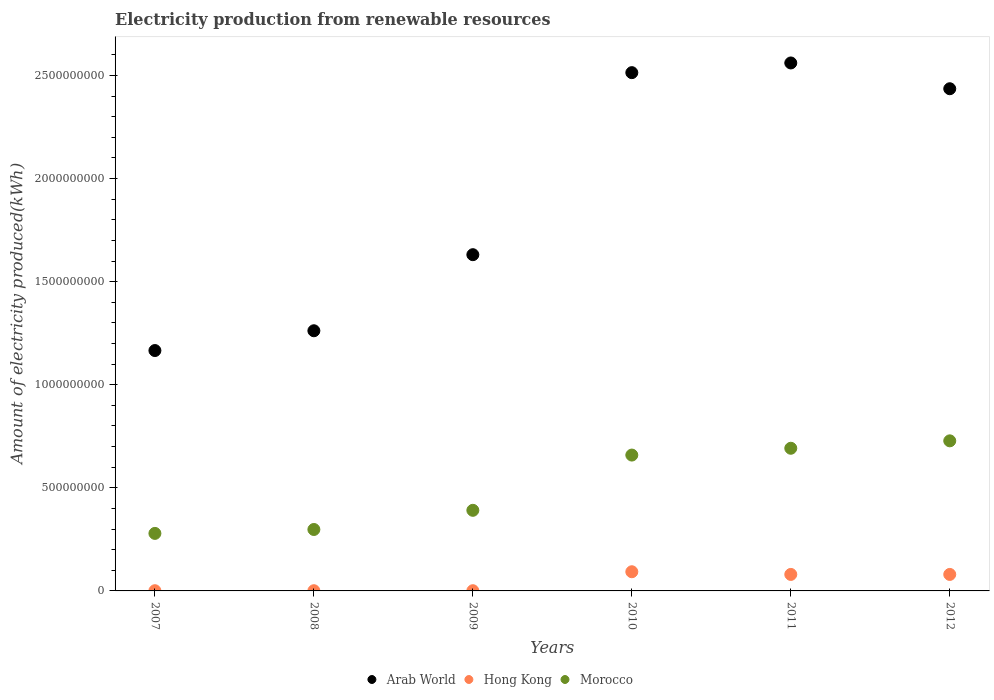How many different coloured dotlines are there?
Provide a short and direct response. 3. What is the amount of electricity produced in Morocco in 2009?
Offer a terse response. 3.91e+08. Across all years, what is the maximum amount of electricity produced in Arab World?
Offer a terse response. 2.56e+09. Across all years, what is the minimum amount of electricity produced in Hong Kong?
Give a very brief answer. 1.00e+06. In which year was the amount of electricity produced in Hong Kong minimum?
Ensure brevity in your answer.  2007. What is the total amount of electricity produced in Arab World in the graph?
Provide a short and direct response. 1.16e+1. What is the difference between the amount of electricity produced in Morocco in 2009 and that in 2012?
Offer a terse response. -3.37e+08. What is the difference between the amount of electricity produced in Morocco in 2012 and the amount of electricity produced in Arab World in 2010?
Your answer should be compact. -1.79e+09. What is the average amount of electricity produced in Arab World per year?
Your answer should be compact. 1.93e+09. In the year 2008, what is the difference between the amount of electricity produced in Hong Kong and amount of electricity produced in Morocco?
Your response must be concise. -2.97e+08. In how many years, is the amount of electricity produced in Arab World greater than 1300000000 kWh?
Make the answer very short. 4. What is the ratio of the amount of electricity produced in Arab World in 2008 to that in 2011?
Provide a short and direct response. 0.49. Is the difference between the amount of electricity produced in Hong Kong in 2010 and 2012 greater than the difference between the amount of electricity produced in Morocco in 2010 and 2012?
Your answer should be compact. Yes. What is the difference between the highest and the second highest amount of electricity produced in Morocco?
Ensure brevity in your answer.  3.60e+07. What is the difference between the highest and the lowest amount of electricity produced in Morocco?
Make the answer very short. 4.49e+08. Is the sum of the amount of electricity produced in Arab World in 2011 and 2012 greater than the maximum amount of electricity produced in Hong Kong across all years?
Your answer should be compact. Yes. Is it the case that in every year, the sum of the amount of electricity produced in Arab World and amount of electricity produced in Hong Kong  is greater than the amount of electricity produced in Morocco?
Keep it short and to the point. Yes. Is the amount of electricity produced in Hong Kong strictly less than the amount of electricity produced in Morocco over the years?
Make the answer very short. Yes. How many dotlines are there?
Offer a terse response. 3. Are the values on the major ticks of Y-axis written in scientific E-notation?
Your answer should be compact. No. Where does the legend appear in the graph?
Give a very brief answer. Bottom center. How many legend labels are there?
Keep it short and to the point. 3. How are the legend labels stacked?
Keep it short and to the point. Horizontal. What is the title of the graph?
Your answer should be compact. Electricity production from renewable resources. Does "Afghanistan" appear as one of the legend labels in the graph?
Offer a terse response. No. What is the label or title of the X-axis?
Your answer should be very brief. Years. What is the label or title of the Y-axis?
Keep it short and to the point. Amount of electricity produced(kWh). What is the Amount of electricity produced(kWh) in Arab World in 2007?
Make the answer very short. 1.17e+09. What is the Amount of electricity produced(kWh) in Hong Kong in 2007?
Provide a short and direct response. 1.00e+06. What is the Amount of electricity produced(kWh) of Morocco in 2007?
Offer a very short reply. 2.79e+08. What is the Amount of electricity produced(kWh) in Arab World in 2008?
Provide a short and direct response. 1.26e+09. What is the Amount of electricity produced(kWh) in Hong Kong in 2008?
Offer a terse response. 1.00e+06. What is the Amount of electricity produced(kWh) of Morocco in 2008?
Your response must be concise. 2.98e+08. What is the Amount of electricity produced(kWh) of Arab World in 2009?
Keep it short and to the point. 1.63e+09. What is the Amount of electricity produced(kWh) of Morocco in 2009?
Your answer should be compact. 3.91e+08. What is the Amount of electricity produced(kWh) in Arab World in 2010?
Give a very brief answer. 2.51e+09. What is the Amount of electricity produced(kWh) in Hong Kong in 2010?
Keep it short and to the point. 9.30e+07. What is the Amount of electricity produced(kWh) in Morocco in 2010?
Provide a short and direct response. 6.59e+08. What is the Amount of electricity produced(kWh) in Arab World in 2011?
Provide a succinct answer. 2.56e+09. What is the Amount of electricity produced(kWh) of Hong Kong in 2011?
Offer a terse response. 8.00e+07. What is the Amount of electricity produced(kWh) of Morocco in 2011?
Offer a terse response. 6.92e+08. What is the Amount of electricity produced(kWh) in Arab World in 2012?
Your answer should be compact. 2.44e+09. What is the Amount of electricity produced(kWh) of Hong Kong in 2012?
Your answer should be compact. 8.00e+07. What is the Amount of electricity produced(kWh) of Morocco in 2012?
Ensure brevity in your answer.  7.28e+08. Across all years, what is the maximum Amount of electricity produced(kWh) of Arab World?
Make the answer very short. 2.56e+09. Across all years, what is the maximum Amount of electricity produced(kWh) of Hong Kong?
Give a very brief answer. 9.30e+07. Across all years, what is the maximum Amount of electricity produced(kWh) in Morocco?
Give a very brief answer. 7.28e+08. Across all years, what is the minimum Amount of electricity produced(kWh) of Arab World?
Provide a short and direct response. 1.17e+09. Across all years, what is the minimum Amount of electricity produced(kWh) of Hong Kong?
Offer a very short reply. 1.00e+06. Across all years, what is the minimum Amount of electricity produced(kWh) in Morocco?
Provide a succinct answer. 2.79e+08. What is the total Amount of electricity produced(kWh) in Arab World in the graph?
Your answer should be compact. 1.16e+1. What is the total Amount of electricity produced(kWh) in Hong Kong in the graph?
Keep it short and to the point. 2.56e+08. What is the total Amount of electricity produced(kWh) of Morocco in the graph?
Offer a very short reply. 3.05e+09. What is the difference between the Amount of electricity produced(kWh) of Arab World in 2007 and that in 2008?
Ensure brevity in your answer.  -9.60e+07. What is the difference between the Amount of electricity produced(kWh) in Hong Kong in 2007 and that in 2008?
Offer a very short reply. 0. What is the difference between the Amount of electricity produced(kWh) of Morocco in 2007 and that in 2008?
Provide a short and direct response. -1.90e+07. What is the difference between the Amount of electricity produced(kWh) in Arab World in 2007 and that in 2009?
Your answer should be compact. -4.65e+08. What is the difference between the Amount of electricity produced(kWh) in Morocco in 2007 and that in 2009?
Keep it short and to the point. -1.12e+08. What is the difference between the Amount of electricity produced(kWh) of Arab World in 2007 and that in 2010?
Provide a succinct answer. -1.35e+09. What is the difference between the Amount of electricity produced(kWh) in Hong Kong in 2007 and that in 2010?
Provide a succinct answer. -9.20e+07. What is the difference between the Amount of electricity produced(kWh) in Morocco in 2007 and that in 2010?
Provide a short and direct response. -3.80e+08. What is the difference between the Amount of electricity produced(kWh) of Arab World in 2007 and that in 2011?
Ensure brevity in your answer.  -1.40e+09. What is the difference between the Amount of electricity produced(kWh) of Hong Kong in 2007 and that in 2011?
Provide a succinct answer. -7.90e+07. What is the difference between the Amount of electricity produced(kWh) in Morocco in 2007 and that in 2011?
Keep it short and to the point. -4.13e+08. What is the difference between the Amount of electricity produced(kWh) of Arab World in 2007 and that in 2012?
Your answer should be compact. -1.27e+09. What is the difference between the Amount of electricity produced(kWh) in Hong Kong in 2007 and that in 2012?
Offer a very short reply. -7.90e+07. What is the difference between the Amount of electricity produced(kWh) in Morocco in 2007 and that in 2012?
Make the answer very short. -4.49e+08. What is the difference between the Amount of electricity produced(kWh) of Arab World in 2008 and that in 2009?
Make the answer very short. -3.69e+08. What is the difference between the Amount of electricity produced(kWh) in Hong Kong in 2008 and that in 2009?
Your answer should be very brief. 0. What is the difference between the Amount of electricity produced(kWh) of Morocco in 2008 and that in 2009?
Make the answer very short. -9.30e+07. What is the difference between the Amount of electricity produced(kWh) in Arab World in 2008 and that in 2010?
Keep it short and to the point. -1.25e+09. What is the difference between the Amount of electricity produced(kWh) of Hong Kong in 2008 and that in 2010?
Keep it short and to the point. -9.20e+07. What is the difference between the Amount of electricity produced(kWh) of Morocco in 2008 and that in 2010?
Offer a terse response. -3.61e+08. What is the difference between the Amount of electricity produced(kWh) in Arab World in 2008 and that in 2011?
Your response must be concise. -1.30e+09. What is the difference between the Amount of electricity produced(kWh) in Hong Kong in 2008 and that in 2011?
Provide a short and direct response. -7.90e+07. What is the difference between the Amount of electricity produced(kWh) in Morocco in 2008 and that in 2011?
Your response must be concise. -3.94e+08. What is the difference between the Amount of electricity produced(kWh) of Arab World in 2008 and that in 2012?
Offer a terse response. -1.17e+09. What is the difference between the Amount of electricity produced(kWh) of Hong Kong in 2008 and that in 2012?
Give a very brief answer. -7.90e+07. What is the difference between the Amount of electricity produced(kWh) of Morocco in 2008 and that in 2012?
Your response must be concise. -4.30e+08. What is the difference between the Amount of electricity produced(kWh) in Arab World in 2009 and that in 2010?
Offer a very short reply. -8.83e+08. What is the difference between the Amount of electricity produced(kWh) in Hong Kong in 2009 and that in 2010?
Keep it short and to the point. -9.20e+07. What is the difference between the Amount of electricity produced(kWh) in Morocco in 2009 and that in 2010?
Your response must be concise. -2.68e+08. What is the difference between the Amount of electricity produced(kWh) in Arab World in 2009 and that in 2011?
Ensure brevity in your answer.  -9.30e+08. What is the difference between the Amount of electricity produced(kWh) of Hong Kong in 2009 and that in 2011?
Offer a very short reply. -7.90e+07. What is the difference between the Amount of electricity produced(kWh) in Morocco in 2009 and that in 2011?
Your response must be concise. -3.01e+08. What is the difference between the Amount of electricity produced(kWh) in Arab World in 2009 and that in 2012?
Make the answer very short. -8.05e+08. What is the difference between the Amount of electricity produced(kWh) of Hong Kong in 2009 and that in 2012?
Offer a terse response. -7.90e+07. What is the difference between the Amount of electricity produced(kWh) in Morocco in 2009 and that in 2012?
Your answer should be compact. -3.37e+08. What is the difference between the Amount of electricity produced(kWh) in Arab World in 2010 and that in 2011?
Your answer should be compact. -4.70e+07. What is the difference between the Amount of electricity produced(kWh) in Hong Kong in 2010 and that in 2011?
Keep it short and to the point. 1.30e+07. What is the difference between the Amount of electricity produced(kWh) in Morocco in 2010 and that in 2011?
Offer a very short reply. -3.30e+07. What is the difference between the Amount of electricity produced(kWh) of Arab World in 2010 and that in 2012?
Offer a terse response. 7.80e+07. What is the difference between the Amount of electricity produced(kWh) in Hong Kong in 2010 and that in 2012?
Make the answer very short. 1.30e+07. What is the difference between the Amount of electricity produced(kWh) in Morocco in 2010 and that in 2012?
Keep it short and to the point. -6.90e+07. What is the difference between the Amount of electricity produced(kWh) in Arab World in 2011 and that in 2012?
Give a very brief answer. 1.25e+08. What is the difference between the Amount of electricity produced(kWh) in Hong Kong in 2011 and that in 2012?
Your answer should be very brief. 0. What is the difference between the Amount of electricity produced(kWh) of Morocco in 2011 and that in 2012?
Your answer should be very brief. -3.60e+07. What is the difference between the Amount of electricity produced(kWh) in Arab World in 2007 and the Amount of electricity produced(kWh) in Hong Kong in 2008?
Provide a short and direct response. 1.16e+09. What is the difference between the Amount of electricity produced(kWh) in Arab World in 2007 and the Amount of electricity produced(kWh) in Morocco in 2008?
Ensure brevity in your answer.  8.68e+08. What is the difference between the Amount of electricity produced(kWh) in Hong Kong in 2007 and the Amount of electricity produced(kWh) in Morocco in 2008?
Make the answer very short. -2.97e+08. What is the difference between the Amount of electricity produced(kWh) in Arab World in 2007 and the Amount of electricity produced(kWh) in Hong Kong in 2009?
Make the answer very short. 1.16e+09. What is the difference between the Amount of electricity produced(kWh) in Arab World in 2007 and the Amount of electricity produced(kWh) in Morocco in 2009?
Offer a terse response. 7.75e+08. What is the difference between the Amount of electricity produced(kWh) in Hong Kong in 2007 and the Amount of electricity produced(kWh) in Morocco in 2009?
Give a very brief answer. -3.90e+08. What is the difference between the Amount of electricity produced(kWh) of Arab World in 2007 and the Amount of electricity produced(kWh) of Hong Kong in 2010?
Provide a succinct answer. 1.07e+09. What is the difference between the Amount of electricity produced(kWh) in Arab World in 2007 and the Amount of electricity produced(kWh) in Morocco in 2010?
Provide a succinct answer. 5.07e+08. What is the difference between the Amount of electricity produced(kWh) in Hong Kong in 2007 and the Amount of electricity produced(kWh) in Morocco in 2010?
Provide a short and direct response. -6.58e+08. What is the difference between the Amount of electricity produced(kWh) of Arab World in 2007 and the Amount of electricity produced(kWh) of Hong Kong in 2011?
Offer a terse response. 1.09e+09. What is the difference between the Amount of electricity produced(kWh) in Arab World in 2007 and the Amount of electricity produced(kWh) in Morocco in 2011?
Ensure brevity in your answer.  4.74e+08. What is the difference between the Amount of electricity produced(kWh) of Hong Kong in 2007 and the Amount of electricity produced(kWh) of Morocco in 2011?
Ensure brevity in your answer.  -6.91e+08. What is the difference between the Amount of electricity produced(kWh) of Arab World in 2007 and the Amount of electricity produced(kWh) of Hong Kong in 2012?
Offer a very short reply. 1.09e+09. What is the difference between the Amount of electricity produced(kWh) in Arab World in 2007 and the Amount of electricity produced(kWh) in Morocco in 2012?
Make the answer very short. 4.38e+08. What is the difference between the Amount of electricity produced(kWh) of Hong Kong in 2007 and the Amount of electricity produced(kWh) of Morocco in 2012?
Make the answer very short. -7.27e+08. What is the difference between the Amount of electricity produced(kWh) of Arab World in 2008 and the Amount of electricity produced(kWh) of Hong Kong in 2009?
Make the answer very short. 1.26e+09. What is the difference between the Amount of electricity produced(kWh) of Arab World in 2008 and the Amount of electricity produced(kWh) of Morocco in 2009?
Give a very brief answer. 8.71e+08. What is the difference between the Amount of electricity produced(kWh) in Hong Kong in 2008 and the Amount of electricity produced(kWh) in Morocco in 2009?
Your response must be concise. -3.90e+08. What is the difference between the Amount of electricity produced(kWh) of Arab World in 2008 and the Amount of electricity produced(kWh) of Hong Kong in 2010?
Your answer should be very brief. 1.17e+09. What is the difference between the Amount of electricity produced(kWh) of Arab World in 2008 and the Amount of electricity produced(kWh) of Morocco in 2010?
Your answer should be very brief. 6.03e+08. What is the difference between the Amount of electricity produced(kWh) of Hong Kong in 2008 and the Amount of electricity produced(kWh) of Morocco in 2010?
Your answer should be very brief. -6.58e+08. What is the difference between the Amount of electricity produced(kWh) in Arab World in 2008 and the Amount of electricity produced(kWh) in Hong Kong in 2011?
Offer a very short reply. 1.18e+09. What is the difference between the Amount of electricity produced(kWh) of Arab World in 2008 and the Amount of electricity produced(kWh) of Morocco in 2011?
Provide a succinct answer. 5.70e+08. What is the difference between the Amount of electricity produced(kWh) of Hong Kong in 2008 and the Amount of electricity produced(kWh) of Morocco in 2011?
Make the answer very short. -6.91e+08. What is the difference between the Amount of electricity produced(kWh) in Arab World in 2008 and the Amount of electricity produced(kWh) in Hong Kong in 2012?
Keep it short and to the point. 1.18e+09. What is the difference between the Amount of electricity produced(kWh) in Arab World in 2008 and the Amount of electricity produced(kWh) in Morocco in 2012?
Your answer should be very brief. 5.34e+08. What is the difference between the Amount of electricity produced(kWh) in Hong Kong in 2008 and the Amount of electricity produced(kWh) in Morocco in 2012?
Offer a terse response. -7.27e+08. What is the difference between the Amount of electricity produced(kWh) of Arab World in 2009 and the Amount of electricity produced(kWh) of Hong Kong in 2010?
Your response must be concise. 1.54e+09. What is the difference between the Amount of electricity produced(kWh) of Arab World in 2009 and the Amount of electricity produced(kWh) of Morocco in 2010?
Provide a succinct answer. 9.72e+08. What is the difference between the Amount of electricity produced(kWh) in Hong Kong in 2009 and the Amount of electricity produced(kWh) in Morocco in 2010?
Provide a short and direct response. -6.58e+08. What is the difference between the Amount of electricity produced(kWh) of Arab World in 2009 and the Amount of electricity produced(kWh) of Hong Kong in 2011?
Your answer should be very brief. 1.55e+09. What is the difference between the Amount of electricity produced(kWh) of Arab World in 2009 and the Amount of electricity produced(kWh) of Morocco in 2011?
Your response must be concise. 9.39e+08. What is the difference between the Amount of electricity produced(kWh) in Hong Kong in 2009 and the Amount of electricity produced(kWh) in Morocco in 2011?
Offer a very short reply. -6.91e+08. What is the difference between the Amount of electricity produced(kWh) in Arab World in 2009 and the Amount of electricity produced(kWh) in Hong Kong in 2012?
Give a very brief answer. 1.55e+09. What is the difference between the Amount of electricity produced(kWh) of Arab World in 2009 and the Amount of electricity produced(kWh) of Morocco in 2012?
Your response must be concise. 9.03e+08. What is the difference between the Amount of electricity produced(kWh) of Hong Kong in 2009 and the Amount of electricity produced(kWh) of Morocco in 2012?
Provide a short and direct response. -7.27e+08. What is the difference between the Amount of electricity produced(kWh) of Arab World in 2010 and the Amount of electricity produced(kWh) of Hong Kong in 2011?
Your response must be concise. 2.43e+09. What is the difference between the Amount of electricity produced(kWh) of Arab World in 2010 and the Amount of electricity produced(kWh) of Morocco in 2011?
Keep it short and to the point. 1.82e+09. What is the difference between the Amount of electricity produced(kWh) in Hong Kong in 2010 and the Amount of electricity produced(kWh) in Morocco in 2011?
Your answer should be very brief. -5.99e+08. What is the difference between the Amount of electricity produced(kWh) of Arab World in 2010 and the Amount of electricity produced(kWh) of Hong Kong in 2012?
Make the answer very short. 2.43e+09. What is the difference between the Amount of electricity produced(kWh) of Arab World in 2010 and the Amount of electricity produced(kWh) of Morocco in 2012?
Make the answer very short. 1.79e+09. What is the difference between the Amount of electricity produced(kWh) of Hong Kong in 2010 and the Amount of electricity produced(kWh) of Morocco in 2012?
Make the answer very short. -6.35e+08. What is the difference between the Amount of electricity produced(kWh) of Arab World in 2011 and the Amount of electricity produced(kWh) of Hong Kong in 2012?
Make the answer very short. 2.48e+09. What is the difference between the Amount of electricity produced(kWh) in Arab World in 2011 and the Amount of electricity produced(kWh) in Morocco in 2012?
Keep it short and to the point. 1.83e+09. What is the difference between the Amount of electricity produced(kWh) of Hong Kong in 2011 and the Amount of electricity produced(kWh) of Morocco in 2012?
Your response must be concise. -6.48e+08. What is the average Amount of electricity produced(kWh) in Arab World per year?
Ensure brevity in your answer.  1.93e+09. What is the average Amount of electricity produced(kWh) of Hong Kong per year?
Give a very brief answer. 4.27e+07. What is the average Amount of electricity produced(kWh) of Morocco per year?
Ensure brevity in your answer.  5.08e+08. In the year 2007, what is the difference between the Amount of electricity produced(kWh) in Arab World and Amount of electricity produced(kWh) in Hong Kong?
Offer a very short reply. 1.16e+09. In the year 2007, what is the difference between the Amount of electricity produced(kWh) of Arab World and Amount of electricity produced(kWh) of Morocco?
Offer a very short reply. 8.87e+08. In the year 2007, what is the difference between the Amount of electricity produced(kWh) of Hong Kong and Amount of electricity produced(kWh) of Morocco?
Ensure brevity in your answer.  -2.78e+08. In the year 2008, what is the difference between the Amount of electricity produced(kWh) in Arab World and Amount of electricity produced(kWh) in Hong Kong?
Give a very brief answer. 1.26e+09. In the year 2008, what is the difference between the Amount of electricity produced(kWh) in Arab World and Amount of electricity produced(kWh) in Morocco?
Provide a succinct answer. 9.64e+08. In the year 2008, what is the difference between the Amount of electricity produced(kWh) of Hong Kong and Amount of electricity produced(kWh) of Morocco?
Provide a succinct answer. -2.97e+08. In the year 2009, what is the difference between the Amount of electricity produced(kWh) in Arab World and Amount of electricity produced(kWh) in Hong Kong?
Offer a terse response. 1.63e+09. In the year 2009, what is the difference between the Amount of electricity produced(kWh) of Arab World and Amount of electricity produced(kWh) of Morocco?
Give a very brief answer. 1.24e+09. In the year 2009, what is the difference between the Amount of electricity produced(kWh) of Hong Kong and Amount of electricity produced(kWh) of Morocco?
Your answer should be very brief. -3.90e+08. In the year 2010, what is the difference between the Amount of electricity produced(kWh) in Arab World and Amount of electricity produced(kWh) in Hong Kong?
Provide a short and direct response. 2.42e+09. In the year 2010, what is the difference between the Amount of electricity produced(kWh) of Arab World and Amount of electricity produced(kWh) of Morocco?
Provide a succinct answer. 1.86e+09. In the year 2010, what is the difference between the Amount of electricity produced(kWh) of Hong Kong and Amount of electricity produced(kWh) of Morocco?
Make the answer very short. -5.66e+08. In the year 2011, what is the difference between the Amount of electricity produced(kWh) in Arab World and Amount of electricity produced(kWh) in Hong Kong?
Keep it short and to the point. 2.48e+09. In the year 2011, what is the difference between the Amount of electricity produced(kWh) of Arab World and Amount of electricity produced(kWh) of Morocco?
Provide a succinct answer. 1.87e+09. In the year 2011, what is the difference between the Amount of electricity produced(kWh) of Hong Kong and Amount of electricity produced(kWh) of Morocco?
Ensure brevity in your answer.  -6.12e+08. In the year 2012, what is the difference between the Amount of electricity produced(kWh) in Arab World and Amount of electricity produced(kWh) in Hong Kong?
Ensure brevity in your answer.  2.36e+09. In the year 2012, what is the difference between the Amount of electricity produced(kWh) of Arab World and Amount of electricity produced(kWh) of Morocco?
Make the answer very short. 1.71e+09. In the year 2012, what is the difference between the Amount of electricity produced(kWh) of Hong Kong and Amount of electricity produced(kWh) of Morocco?
Offer a terse response. -6.48e+08. What is the ratio of the Amount of electricity produced(kWh) of Arab World in 2007 to that in 2008?
Ensure brevity in your answer.  0.92. What is the ratio of the Amount of electricity produced(kWh) in Hong Kong in 2007 to that in 2008?
Provide a short and direct response. 1. What is the ratio of the Amount of electricity produced(kWh) in Morocco in 2007 to that in 2008?
Your answer should be compact. 0.94. What is the ratio of the Amount of electricity produced(kWh) of Arab World in 2007 to that in 2009?
Provide a short and direct response. 0.71. What is the ratio of the Amount of electricity produced(kWh) in Morocco in 2007 to that in 2009?
Your response must be concise. 0.71. What is the ratio of the Amount of electricity produced(kWh) in Arab World in 2007 to that in 2010?
Your response must be concise. 0.46. What is the ratio of the Amount of electricity produced(kWh) in Hong Kong in 2007 to that in 2010?
Make the answer very short. 0.01. What is the ratio of the Amount of electricity produced(kWh) of Morocco in 2007 to that in 2010?
Offer a terse response. 0.42. What is the ratio of the Amount of electricity produced(kWh) of Arab World in 2007 to that in 2011?
Offer a very short reply. 0.46. What is the ratio of the Amount of electricity produced(kWh) in Hong Kong in 2007 to that in 2011?
Provide a succinct answer. 0.01. What is the ratio of the Amount of electricity produced(kWh) in Morocco in 2007 to that in 2011?
Make the answer very short. 0.4. What is the ratio of the Amount of electricity produced(kWh) in Arab World in 2007 to that in 2012?
Provide a succinct answer. 0.48. What is the ratio of the Amount of electricity produced(kWh) in Hong Kong in 2007 to that in 2012?
Make the answer very short. 0.01. What is the ratio of the Amount of electricity produced(kWh) of Morocco in 2007 to that in 2012?
Provide a short and direct response. 0.38. What is the ratio of the Amount of electricity produced(kWh) in Arab World in 2008 to that in 2009?
Ensure brevity in your answer.  0.77. What is the ratio of the Amount of electricity produced(kWh) of Hong Kong in 2008 to that in 2009?
Your answer should be very brief. 1. What is the ratio of the Amount of electricity produced(kWh) in Morocco in 2008 to that in 2009?
Your answer should be compact. 0.76. What is the ratio of the Amount of electricity produced(kWh) in Arab World in 2008 to that in 2010?
Offer a very short reply. 0.5. What is the ratio of the Amount of electricity produced(kWh) in Hong Kong in 2008 to that in 2010?
Ensure brevity in your answer.  0.01. What is the ratio of the Amount of electricity produced(kWh) in Morocco in 2008 to that in 2010?
Make the answer very short. 0.45. What is the ratio of the Amount of electricity produced(kWh) of Arab World in 2008 to that in 2011?
Provide a short and direct response. 0.49. What is the ratio of the Amount of electricity produced(kWh) in Hong Kong in 2008 to that in 2011?
Offer a very short reply. 0.01. What is the ratio of the Amount of electricity produced(kWh) in Morocco in 2008 to that in 2011?
Offer a very short reply. 0.43. What is the ratio of the Amount of electricity produced(kWh) of Arab World in 2008 to that in 2012?
Your answer should be compact. 0.52. What is the ratio of the Amount of electricity produced(kWh) of Hong Kong in 2008 to that in 2012?
Ensure brevity in your answer.  0.01. What is the ratio of the Amount of electricity produced(kWh) of Morocco in 2008 to that in 2012?
Your response must be concise. 0.41. What is the ratio of the Amount of electricity produced(kWh) of Arab World in 2009 to that in 2010?
Make the answer very short. 0.65. What is the ratio of the Amount of electricity produced(kWh) in Hong Kong in 2009 to that in 2010?
Keep it short and to the point. 0.01. What is the ratio of the Amount of electricity produced(kWh) in Morocco in 2009 to that in 2010?
Keep it short and to the point. 0.59. What is the ratio of the Amount of electricity produced(kWh) in Arab World in 2009 to that in 2011?
Ensure brevity in your answer.  0.64. What is the ratio of the Amount of electricity produced(kWh) in Hong Kong in 2009 to that in 2011?
Your response must be concise. 0.01. What is the ratio of the Amount of electricity produced(kWh) of Morocco in 2009 to that in 2011?
Your response must be concise. 0.56. What is the ratio of the Amount of electricity produced(kWh) of Arab World in 2009 to that in 2012?
Provide a short and direct response. 0.67. What is the ratio of the Amount of electricity produced(kWh) in Hong Kong in 2009 to that in 2012?
Your response must be concise. 0.01. What is the ratio of the Amount of electricity produced(kWh) in Morocco in 2009 to that in 2012?
Ensure brevity in your answer.  0.54. What is the ratio of the Amount of electricity produced(kWh) in Arab World in 2010 to that in 2011?
Your answer should be very brief. 0.98. What is the ratio of the Amount of electricity produced(kWh) of Hong Kong in 2010 to that in 2011?
Your answer should be compact. 1.16. What is the ratio of the Amount of electricity produced(kWh) of Morocco in 2010 to that in 2011?
Your answer should be compact. 0.95. What is the ratio of the Amount of electricity produced(kWh) of Arab World in 2010 to that in 2012?
Your answer should be compact. 1.03. What is the ratio of the Amount of electricity produced(kWh) of Hong Kong in 2010 to that in 2012?
Keep it short and to the point. 1.16. What is the ratio of the Amount of electricity produced(kWh) of Morocco in 2010 to that in 2012?
Offer a very short reply. 0.91. What is the ratio of the Amount of electricity produced(kWh) of Arab World in 2011 to that in 2012?
Give a very brief answer. 1.05. What is the ratio of the Amount of electricity produced(kWh) in Hong Kong in 2011 to that in 2012?
Ensure brevity in your answer.  1. What is the ratio of the Amount of electricity produced(kWh) in Morocco in 2011 to that in 2012?
Provide a succinct answer. 0.95. What is the difference between the highest and the second highest Amount of electricity produced(kWh) in Arab World?
Keep it short and to the point. 4.70e+07. What is the difference between the highest and the second highest Amount of electricity produced(kWh) in Hong Kong?
Keep it short and to the point. 1.30e+07. What is the difference between the highest and the second highest Amount of electricity produced(kWh) in Morocco?
Provide a succinct answer. 3.60e+07. What is the difference between the highest and the lowest Amount of electricity produced(kWh) of Arab World?
Provide a succinct answer. 1.40e+09. What is the difference between the highest and the lowest Amount of electricity produced(kWh) of Hong Kong?
Provide a succinct answer. 9.20e+07. What is the difference between the highest and the lowest Amount of electricity produced(kWh) of Morocco?
Offer a very short reply. 4.49e+08. 